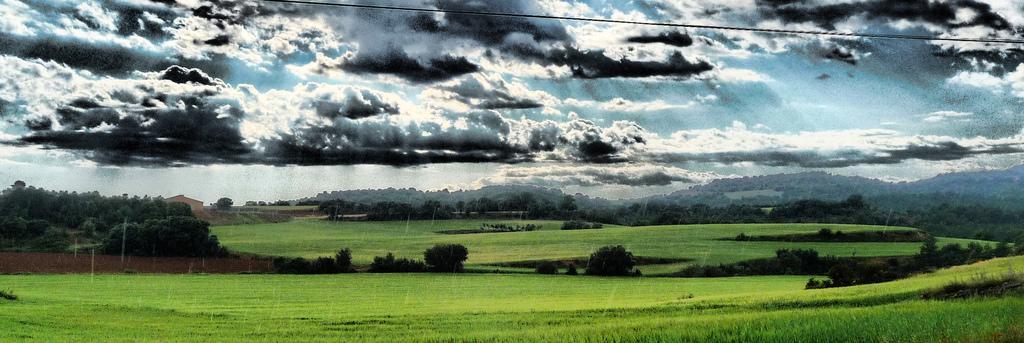Please provide a concise description of this image. In this image we can see grass, bushes, trees, buildings, hills and sky with clouds. 